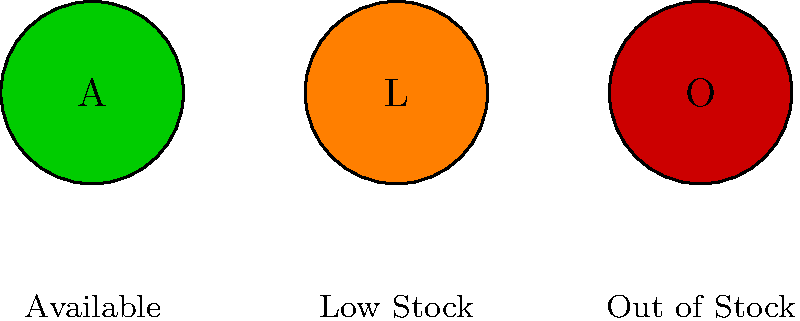In developing a scalable icon system for representing stock statuses in promotional materials, which color combination and design approach would be most effective for ensuring clarity and accessibility across various media types? To develop an effective scalable icon system for stock statuses, consider the following steps:

1. Color selection:
   - Green (Available): Universally associated with "go" or positive status.
   - Orange (Low Stock): Indicates caution or limited availability.
   - Red (Out of Stock): Signifies stop or unavailability.

2. Design simplicity:
   - Use simple geometric shapes (circles) for easy recognition at various sizes.
   - Incorporate single-letter labels (A, L, O) for additional clarity.

3. Contrast and accessibility:
   - Ensure high contrast between the icon color and background.
   - Choose colors that are distinguishable for colorblind users.

4. Scalability:
   - Use vector-based designs for lossless scaling across different media.
   - Keep details minimal to maintain clarity at small sizes.

5. Consistency:
   - Maintain consistent icon sizes and shapes across all stock statuses.
   - Use a uniform style for labels and legends.

6. Legibility:
   - Include a legend for clear interpretation of the icons.
   - Use appropriate font sizes for labels and legends to ensure readability.

7. Versatility:
   - Design icons that work well in both digital and print media.
   - Consider how the icons will appear in grayscale for certain print applications.

8. Cultural sensitivity:
   - Ensure color choices don't have negative connotations in target markets.

9. Brand alignment:
   - While using standard colors, consider slight adjustments to align with brand guidelines.

10. Testing:
    - Conduct user testing to verify the effectiveness of the icon system across different contexts and user groups.

This approach creates a clear, accessible, and scalable icon system that effectively communicates stock status across various promotional materials.
Answer: Simple, high-contrast geometric icons with universal color coding (green/orange/red), clear labeling, and consistent design across all stock statuses. 